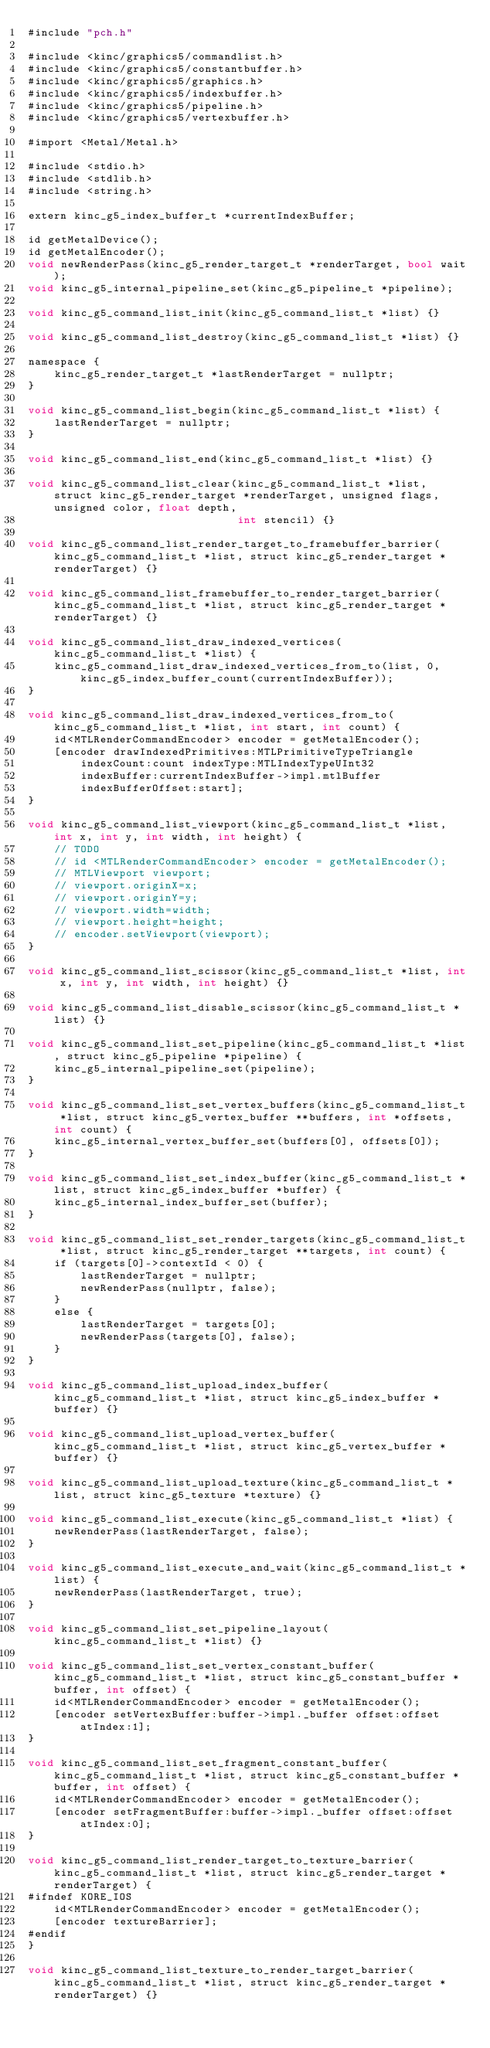Convert code to text. <code><loc_0><loc_0><loc_500><loc_500><_ObjectiveC_>#include "pch.h"

#include <kinc/graphics5/commandlist.h>
#include <kinc/graphics5/constantbuffer.h>
#include <kinc/graphics5/graphics.h>
#include <kinc/graphics5/indexbuffer.h>
#include <kinc/graphics5/pipeline.h>
#include <kinc/graphics5/vertexbuffer.h>

#import <Metal/Metal.h>

#include <stdio.h>
#include <stdlib.h>
#include <string.h>

extern kinc_g5_index_buffer_t *currentIndexBuffer;

id getMetalDevice();
id getMetalEncoder();
void newRenderPass(kinc_g5_render_target_t *renderTarget, bool wait);
void kinc_g5_internal_pipeline_set(kinc_g5_pipeline_t *pipeline);

void kinc_g5_command_list_init(kinc_g5_command_list_t *list) {}

void kinc_g5_command_list_destroy(kinc_g5_command_list_t *list) {}

namespace {
	kinc_g5_render_target_t *lastRenderTarget = nullptr;
}

void kinc_g5_command_list_begin(kinc_g5_command_list_t *list) {
	lastRenderTarget = nullptr;
}

void kinc_g5_command_list_end(kinc_g5_command_list_t *list) {}

void kinc_g5_command_list_clear(kinc_g5_command_list_t *list, struct kinc_g5_render_target *renderTarget, unsigned flags, unsigned color, float depth,
								int stencil) {}

void kinc_g5_command_list_render_target_to_framebuffer_barrier(kinc_g5_command_list_t *list, struct kinc_g5_render_target *renderTarget) {}

void kinc_g5_command_list_framebuffer_to_render_target_barrier(kinc_g5_command_list_t *list, struct kinc_g5_render_target *renderTarget) {}

void kinc_g5_command_list_draw_indexed_vertices(kinc_g5_command_list_t *list) {
	kinc_g5_command_list_draw_indexed_vertices_from_to(list, 0, kinc_g5_index_buffer_count(currentIndexBuffer));
}

void kinc_g5_command_list_draw_indexed_vertices_from_to(kinc_g5_command_list_t *list, int start, int count) {
	id<MTLRenderCommandEncoder> encoder = getMetalEncoder();
	[encoder drawIndexedPrimitives:MTLPrimitiveTypeTriangle
		indexCount:count indexType:MTLIndexTypeUInt32
		indexBuffer:currentIndexBuffer->impl.mtlBuffer
		indexBufferOffset:start];
}

void kinc_g5_command_list_viewport(kinc_g5_command_list_t *list, int x, int y, int width, int height) {
	// TODO
	// id <MTLRenderCommandEncoder> encoder = getMetalEncoder();
	// MTLViewport viewport;
	// viewport.originX=x;
	// viewport.originY=y;
	// viewport.width=width;
	// viewport.height=height;
	// encoder.setViewport(viewport);
}

void kinc_g5_command_list_scissor(kinc_g5_command_list_t *list, int x, int y, int width, int height) {}

void kinc_g5_command_list_disable_scissor(kinc_g5_command_list_t *list) {}

void kinc_g5_command_list_set_pipeline(kinc_g5_command_list_t *list, struct kinc_g5_pipeline *pipeline) {
	kinc_g5_internal_pipeline_set(pipeline);
}

void kinc_g5_command_list_set_vertex_buffers(kinc_g5_command_list_t *list, struct kinc_g5_vertex_buffer **buffers, int *offsets, int count) {
	kinc_g5_internal_vertex_buffer_set(buffers[0], offsets[0]);
}

void kinc_g5_command_list_set_index_buffer(kinc_g5_command_list_t *list, struct kinc_g5_index_buffer *buffer) {
	kinc_g5_internal_index_buffer_set(buffer);
}

void kinc_g5_command_list_set_render_targets(kinc_g5_command_list_t *list, struct kinc_g5_render_target **targets, int count) {
	if (targets[0]->contextId < 0) {
		lastRenderTarget = nullptr;
		newRenderPass(nullptr, false);
	}
	else {
		lastRenderTarget = targets[0];
		newRenderPass(targets[0], false);
	}
}

void kinc_g5_command_list_upload_index_buffer(kinc_g5_command_list_t *list, struct kinc_g5_index_buffer *buffer) {}

void kinc_g5_command_list_upload_vertex_buffer(kinc_g5_command_list_t *list, struct kinc_g5_vertex_buffer *buffer) {}

void kinc_g5_command_list_upload_texture(kinc_g5_command_list_t *list, struct kinc_g5_texture *texture) {}

void kinc_g5_command_list_execute(kinc_g5_command_list_t *list) {
	newRenderPass(lastRenderTarget, false);
}

void kinc_g5_command_list_execute_and_wait(kinc_g5_command_list_t *list) {
	newRenderPass(lastRenderTarget, true);
}

void kinc_g5_command_list_set_pipeline_layout(kinc_g5_command_list_t *list) {}

void kinc_g5_command_list_set_vertex_constant_buffer(kinc_g5_command_list_t *list, struct kinc_g5_constant_buffer *buffer, int offset) {
	id<MTLRenderCommandEncoder> encoder = getMetalEncoder();
	[encoder setVertexBuffer:buffer->impl._buffer offset:offset atIndex:1];
}

void kinc_g5_command_list_set_fragment_constant_buffer(kinc_g5_command_list_t *list, struct kinc_g5_constant_buffer *buffer, int offset) {
	id<MTLRenderCommandEncoder> encoder = getMetalEncoder();
	[encoder setFragmentBuffer:buffer->impl._buffer offset:offset atIndex:0];
}

void kinc_g5_command_list_render_target_to_texture_barrier(kinc_g5_command_list_t *list, struct kinc_g5_render_target *renderTarget) {
#ifndef KORE_IOS
	id<MTLRenderCommandEncoder> encoder = getMetalEncoder();
	[encoder textureBarrier];
#endif
}

void kinc_g5_command_list_texture_to_render_target_barrier(kinc_g5_command_list_t *list, struct kinc_g5_render_target *renderTarget) {}
</code> 